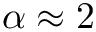<formula> <loc_0><loc_0><loc_500><loc_500>\alpha \approx 2</formula> 